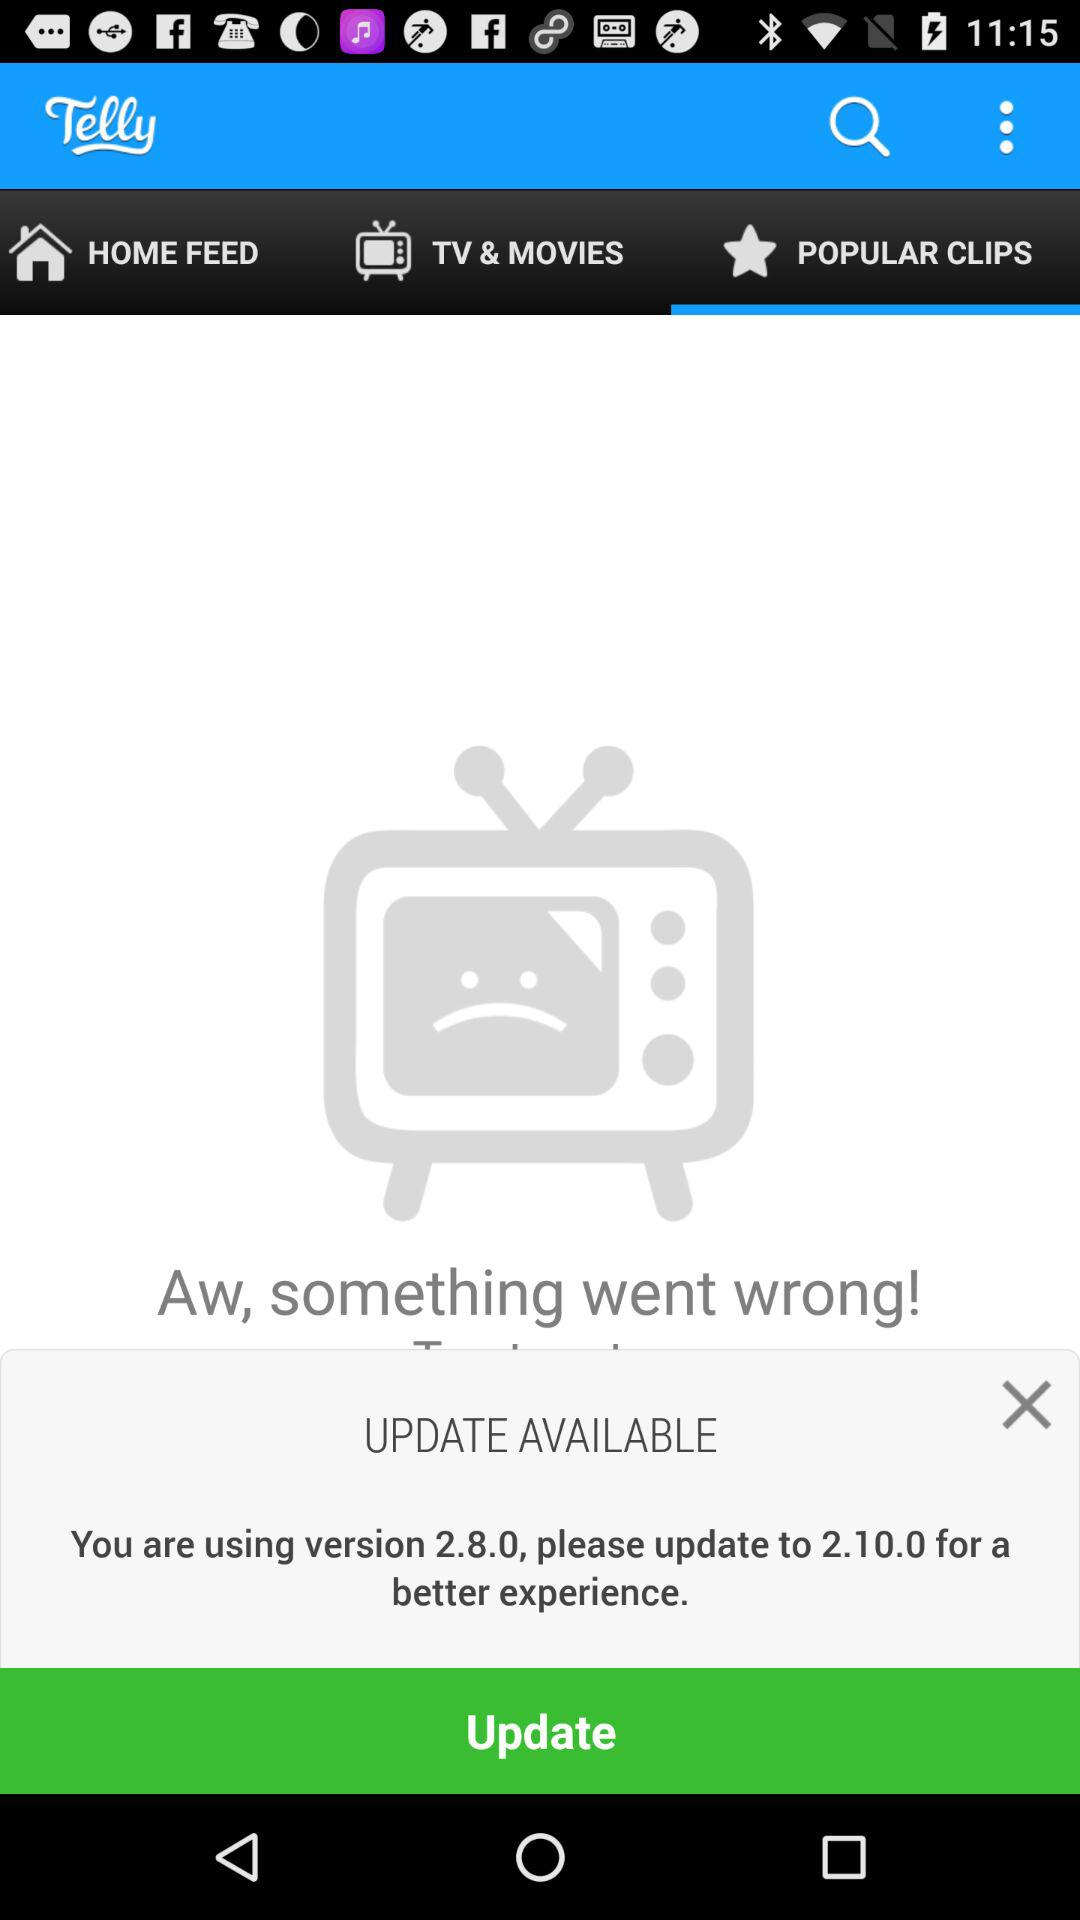What are the selected movie titles?
When the provided information is insufficient, respond with <no answer>. <no answer> 